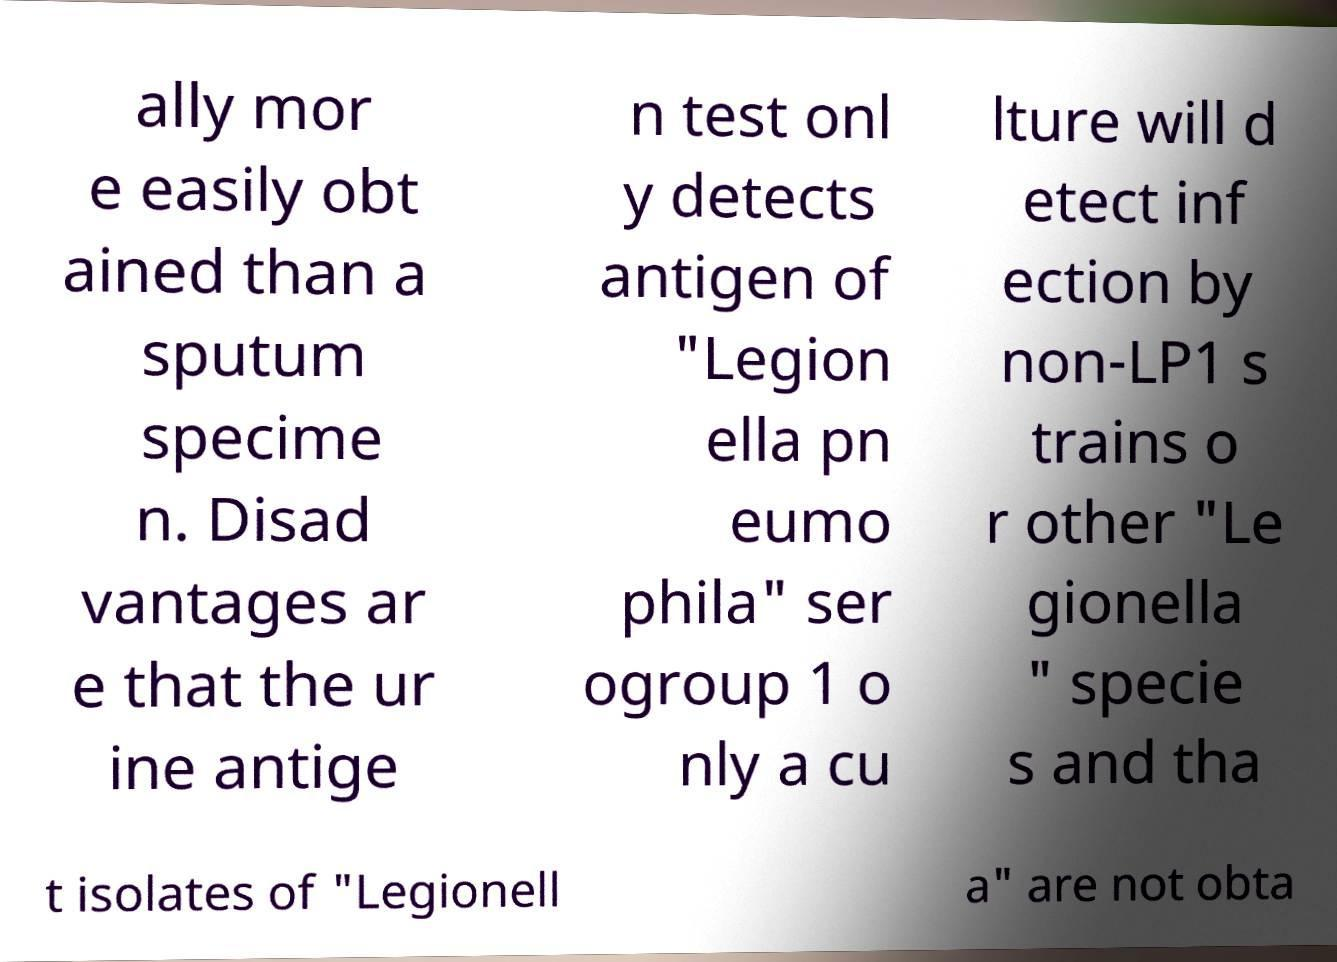For documentation purposes, I need the text within this image transcribed. Could you provide that? ally mor e easily obt ained than a sputum specime n. Disad vantages ar e that the ur ine antige n test onl y detects antigen of "Legion ella pn eumo phila" ser ogroup 1 o nly a cu lture will d etect inf ection by non-LP1 s trains o r other "Le gionella " specie s and tha t isolates of "Legionell a" are not obta 